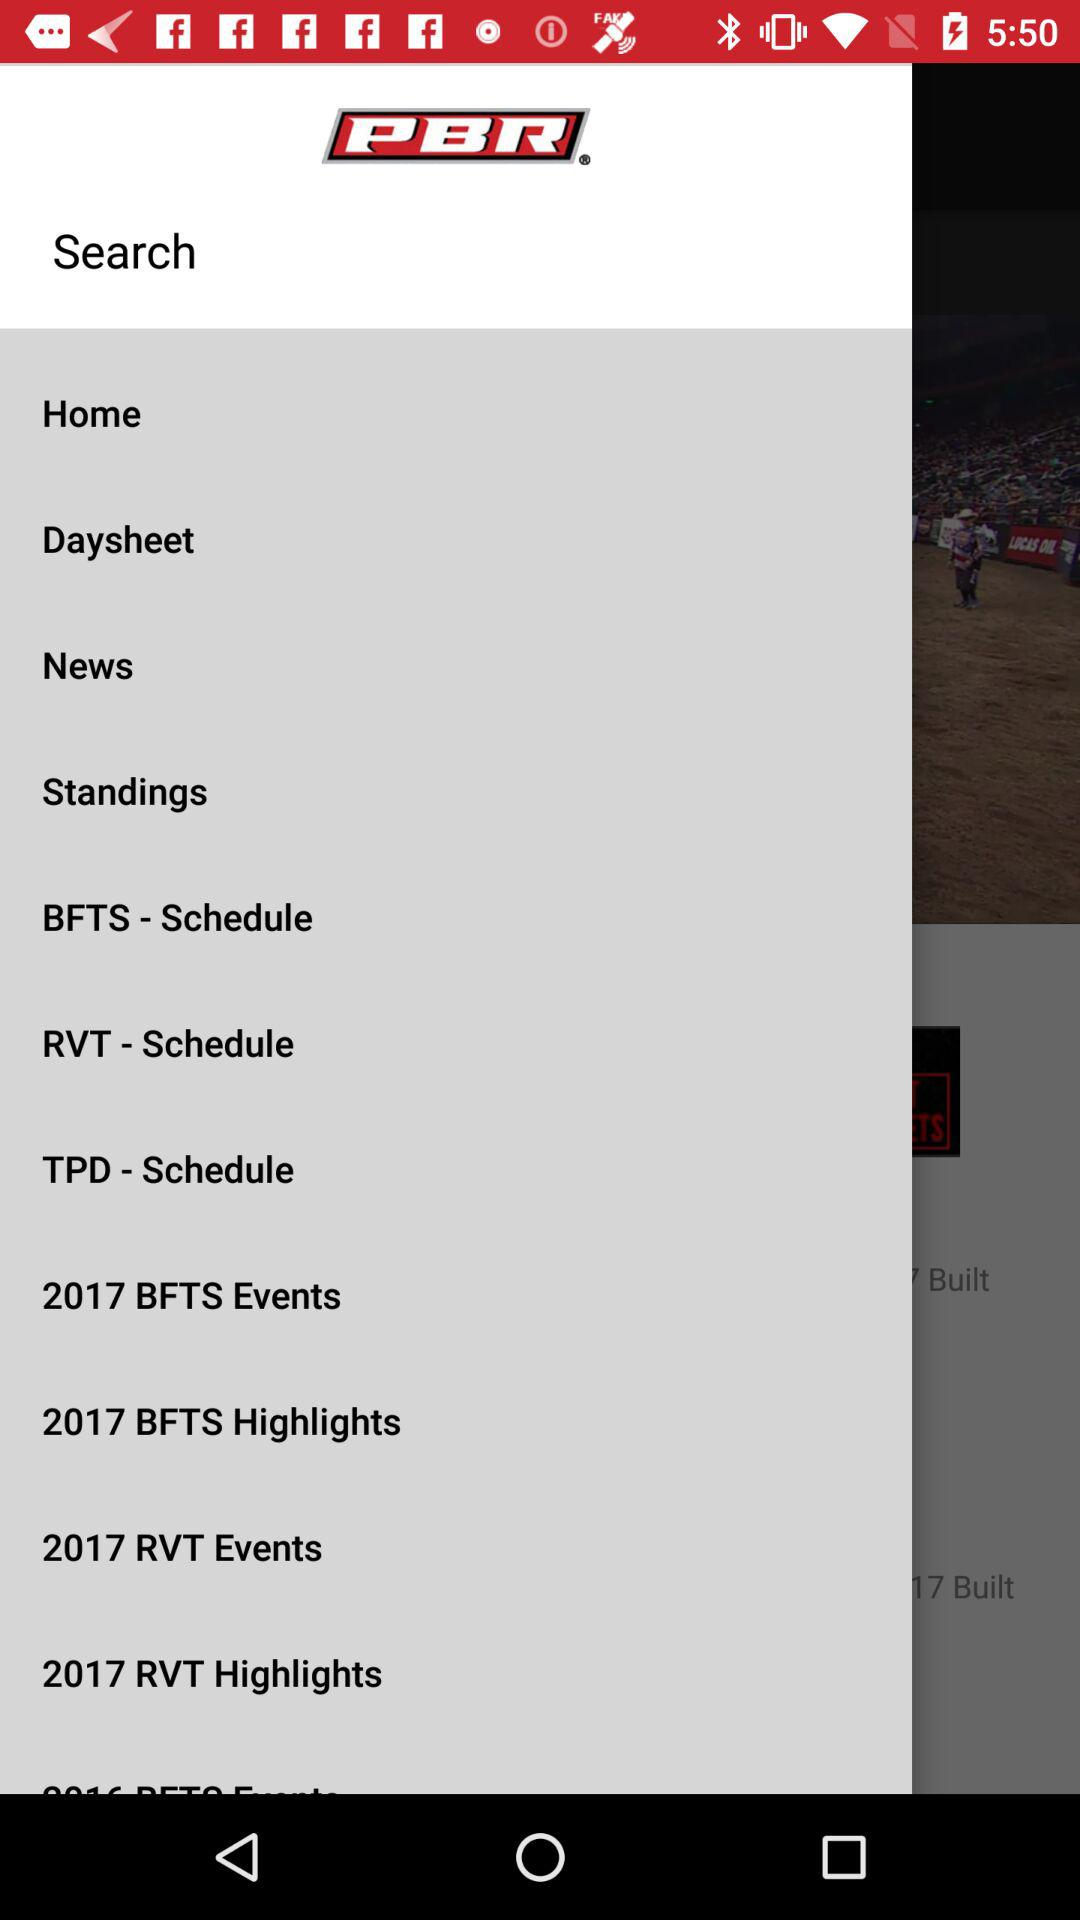What is the application name? The application name is "PBR". 